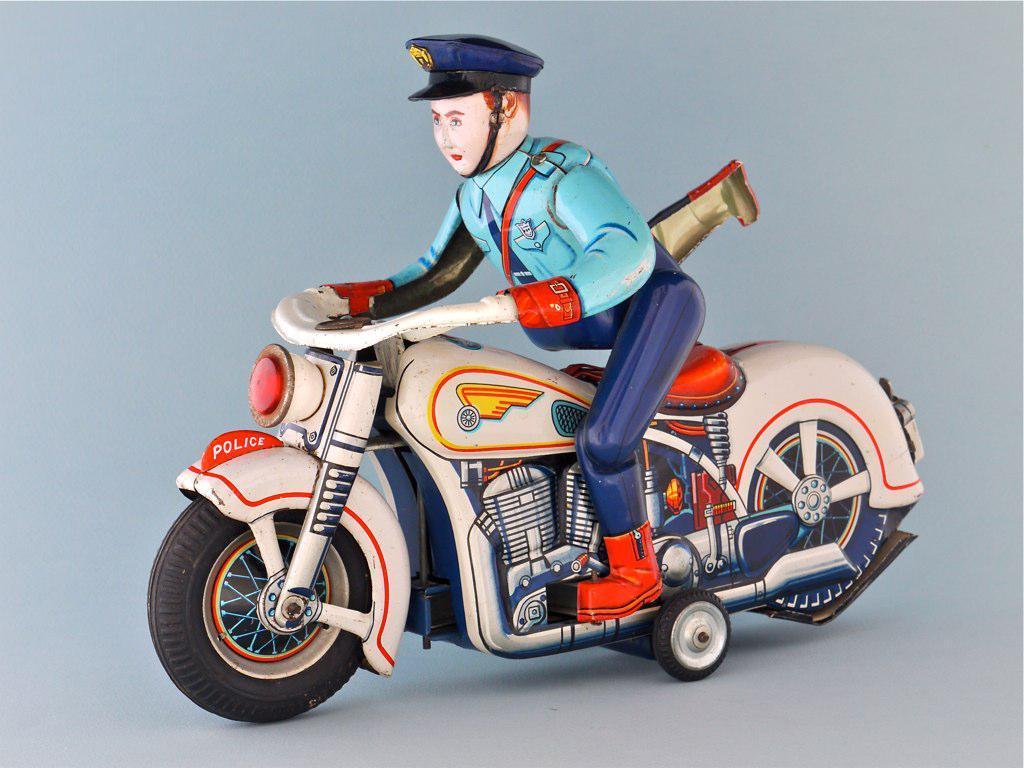Describe this image in one or two sentences. In the center of the picture there is toy of a policeman, on a bike. The picture has white surface. 